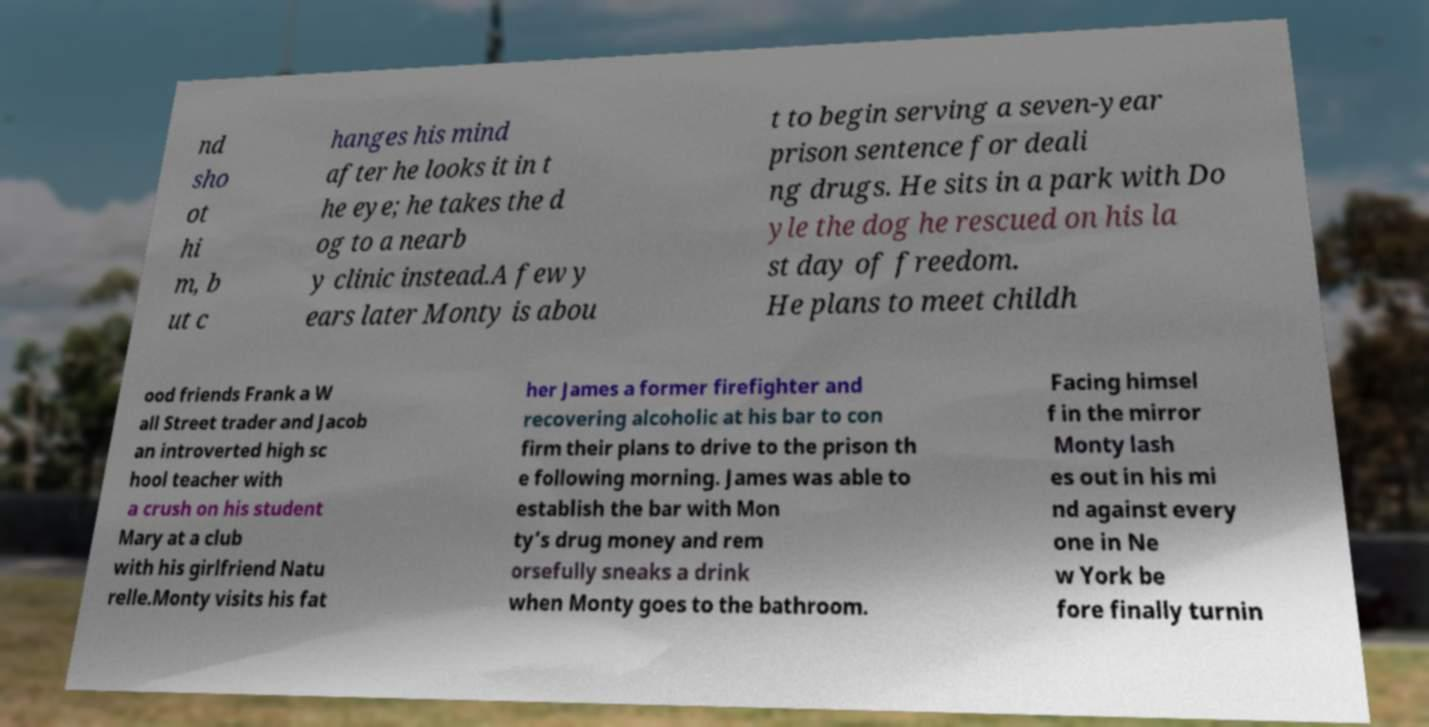I need the written content from this picture converted into text. Can you do that? nd sho ot hi m, b ut c hanges his mind after he looks it in t he eye; he takes the d og to a nearb y clinic instead.A few y ears later Monty is abou t to begin serving a seven-year prison sentence for deali ng drugs. He sits in a park with Do yle the dog he rescued on his la st day of freedom. He plans to meet childh ood friends Frank a W all Street trader and Jacob an introverted high sc hool teacher with a crush on his student Mary at a club with his girlfriend Natu relle.Monty visits his fat her James a former firefighter and recovering alcoholic at his bar to con firm their plans to drive to the prison th e following morning. James was able to establish the bar with Mon ty’s drug money and rem orsefully sneaks a drink when Monty goes to the bathroom. Facing himsel f in the mirror Monty lash es out in his mi nd against every one in Ne w York be fore finally turnin 